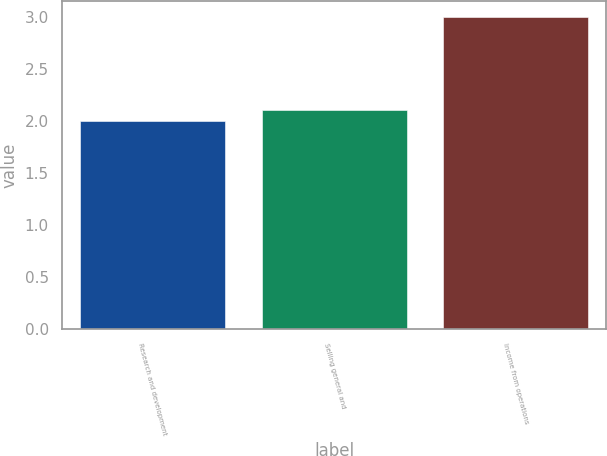Convert chart to OTSL. <chart><loc_0><loc_0><loc_500><loc_500><bar_chart><fcel>Research and development<fcel>Selling general and<fcel>Income from operations<nl><fcel>2<fcel>2.1<fcel>3<nl></chart> 